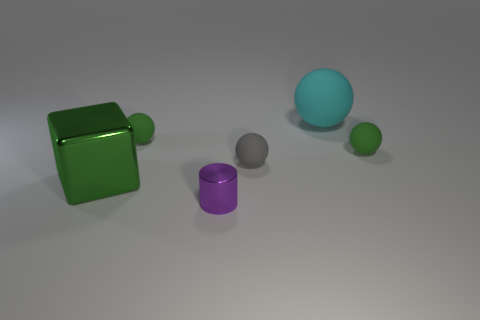There is another large thing that is the same shape as the gray object; what color is it?
Provide a short and direct response. Cyan. Is there anything else that is the same shape as the large cyan matte thing?
Provide a succinct answer. Yes. Is the number of purple things that are on the left side of the large green cube greater than the number of tiny metal cylinders in front of the big matte object?
Provide a short and direct response. No. How big is the green matte ball left of the small green rubber thing in front of the tiny green ball that is to the left of the big matte object?
Offer a very short reply. Small. Is the material of the large ball the same as the small green sphere right of the big cyan matte thing?
Give a very brief answer. Yes. Is the large rubber object the same shape as the gray rubber object?
Give a very brief answer. Yes. How many other things are there of the same material as the small cylinder?
Your response must be concise. 1. How many other purple things are the same shape as the tiny shiny object?
Give a very brief answer. 0. The thing that is left of the tiny purple metallic object and in front of the small gray sphere is what color?
Offer a very short reply. Green. How many big yellow rubber objects are there?
Provide a short and direct response. 0. 